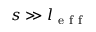<formula> <loc_0><loc_0><loc_500><loc_500>s \gg l _ { e f f }</formula> 